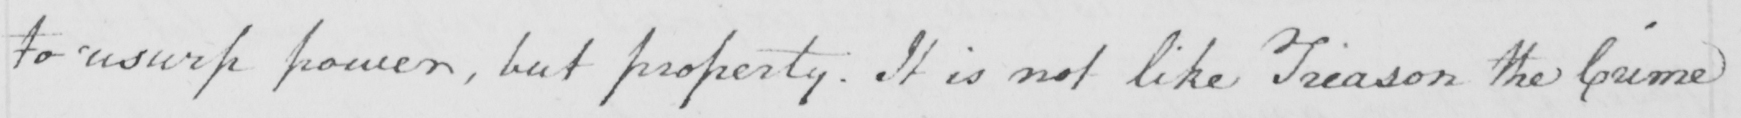Can you tell me what this handwritten text says? to usurp power , but property . It is not like Treason the Crime 